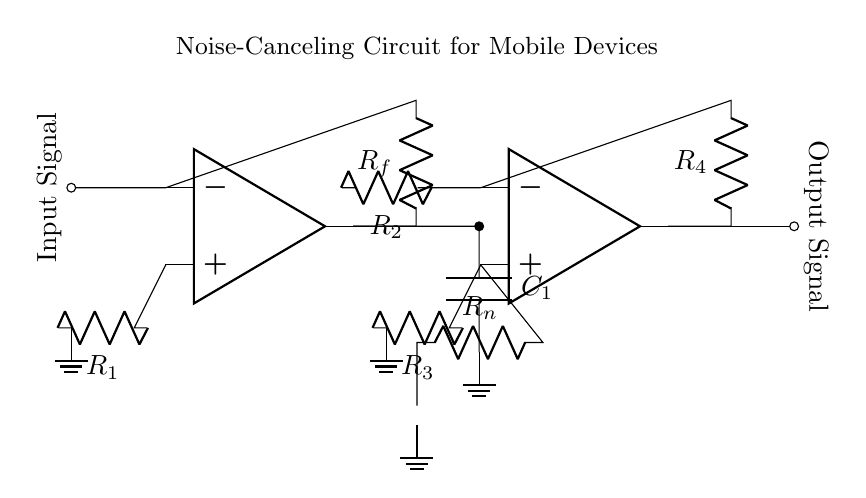What is the primary function of the op-amps in this circuit? The op-amps amplify the input signal and process it to cancel out noise, enhancing the overall audio experience.
Answer: Amplification How many resistors are present in the circuit? The circuit contains four resistors, labeled R1, R2, R3, and R4. The count is determined by visually identifying each resistor in the diagram.
Answer: Four What is the role of capacitor C1 in the circuit? Capacitor C1 is used to filter out high-frequency noise from the amplified signal, allowing the low-frequency audio to pass through more effectively.
Answer: Filtering What type of circuit is depicted? This is a noise-canceling circuit specifically designed for mobile devices to improve audio quality by reducing unwanted noise.
Answer: Noise-canceling Which component is connected to the noise source? The resistor Rn is connected to the noise source, serving to link the noise with the input of the second op-amp for processing.
Answer: Rn What are the two output signals in the circuit? The output signals include both the amplified audio signal and the processed noise cancellation signal from the two op-amps. Identifying these is based on the outputs of each op-amp in the diagram.
Answer: Amplified audio signal and noise cancellation signal 